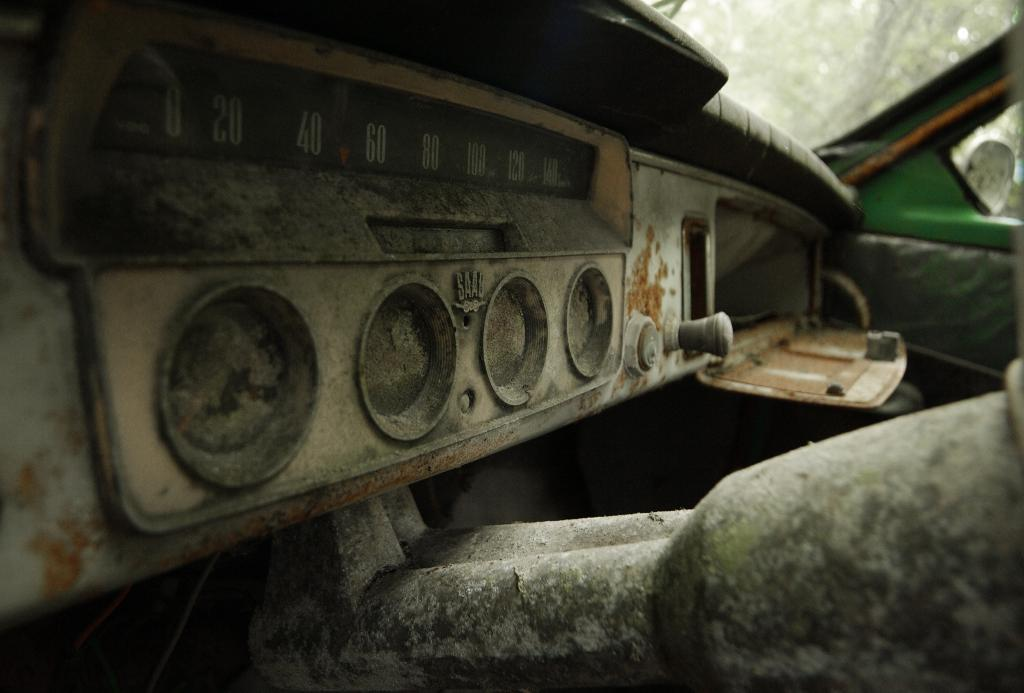What is the main subject of the image? The main subject of the image is a vehicle. What specific features can be seen on the vehicle? The vehicle has speedometers and rust. Can you tell me how many plants are growing in the harbor near the vehicle in the image? There is no harbor or plants present in the image; it only features a vehicle with speedometers and rust. 